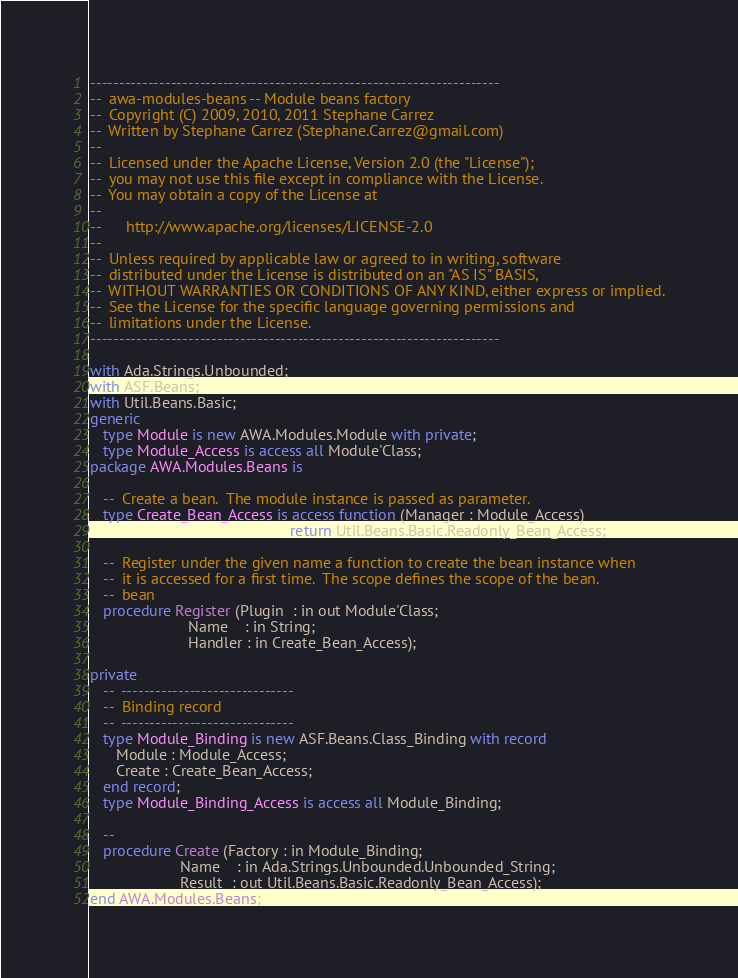<code> <loc_0><loc_0><loc_500><loc_500><_Ada_>-----------------------------------------------------------------------
--  awa-modules-beans -- Module beans factory
--  Copyright (C) 2009, 2010, 2011 Stephane Carrez
--  Written by Stephane Carrez (Stephane.Carrez@gmail.com)
--
--  Licensed under the Apache License, Version 2.0 (the "License");
--  you may not use this file except in compliance with the License.
--  You may obtain a copy of the License at
--
--      http://www.apache.org/licenses/LICENSE-2.0
--
--  Unless required by applicable law or agreed to in writing, software
--  distributed under the License is distributed on an "AS IS" BASIS,
--  WITHOUT WARRANTIES OR CONDITIONS OF ANY KIND, either express or implied.
--  See the License for the specific language governing permissions and
--  limitations under the License.
-----------------------------------------------------------------------

with Ada.Strings.Unbounded;
with ASF.Beans;
with Util.Beans.Basic;
generic
   type Module is new AWA.Modules.Module with private;
   type Module_Access is access all Module'Class;
package AWA.Modules.Beans is

   --  Create a bean.  The module instance is passed as parameter.
   type Create_Bean_Access is access function (Manager : Module_Access)
                                               return Util.Beans.Basic.Readonly_Bean_Access;

   --  Register under the given name a function to create the bean instance when
   --  it is accessed for a first time.  The scope defines the scope of the bean.
   --  bean
   procedure Register (Plugin  : in out Module'Class;
                       Name    : in String;
                       Handler : in Create_Bean_Access);

private
   --  ------------------------------
   --  Binding record
   --  ------------------------------
   type Module_Binding is new ASF.Beans.Class_Binding with record
      Module : Module_Access;
      Create : Create_Bean_Access;
   end record;
   type Module_Binding_Access is access all Module_Binding;

   --
   procedure Create (Factory : in Module_Binding;
                     Name    : in Ada.Strings.Unbounded.Unbounded_String;
                     Result  : out Util.Beans.Basic.Readonly_Bean_Access);
end AWA.Modules.Beans;
</code> 